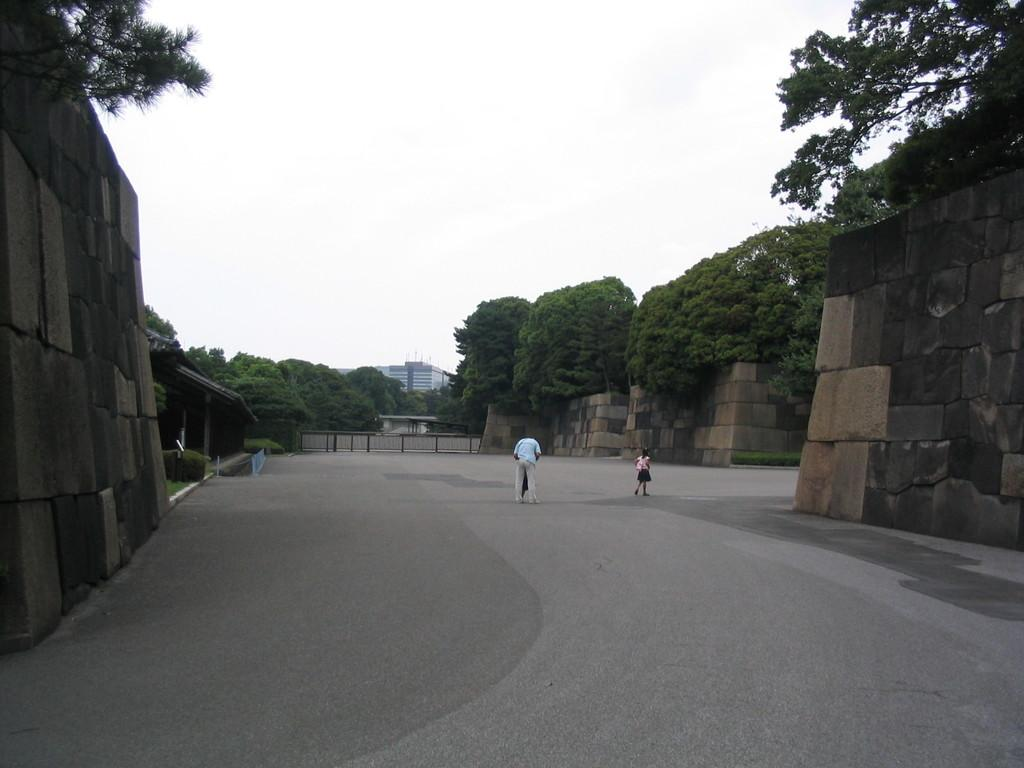How many people are present on the road in the image? There are two persons on the road in the image. What structures can be seen in the image? There is a wall, a fence, a building, and a sky visible in the image. What type of vegetation is present in the image? There are plants and trees in the image. What part of the natural environment is visible in the image? The sky is visible in the background of the image. Is there a railway visible in the image? No, there is no railway present in the image. What type of crime is being committed in the image? There is no crime being committed in the image; it simply shows two persons on the road, a wall, a fence, plants, trees, a building, and the sky. 